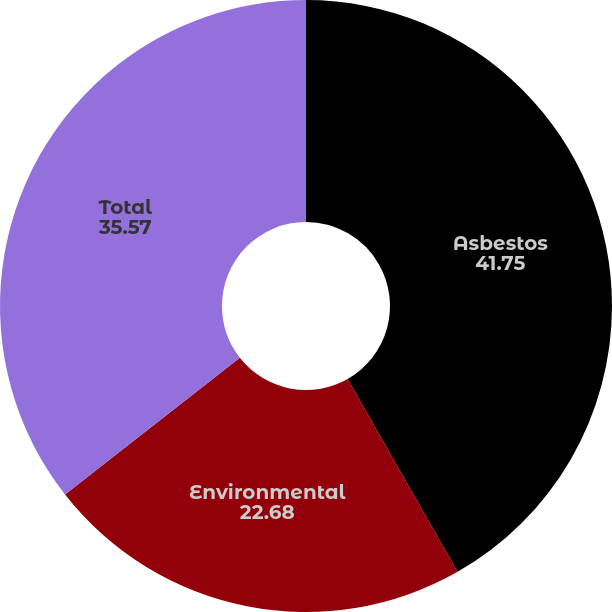Convert chart. <chart><loc_0><loc_0><loc_500><loc_500><pie_chart><fcel>Asbestos<fcel>Environmental<fcel>Total<nl><fcel>41.75%<fcel>22.68%<fcel>35.57%<nl></chart> 